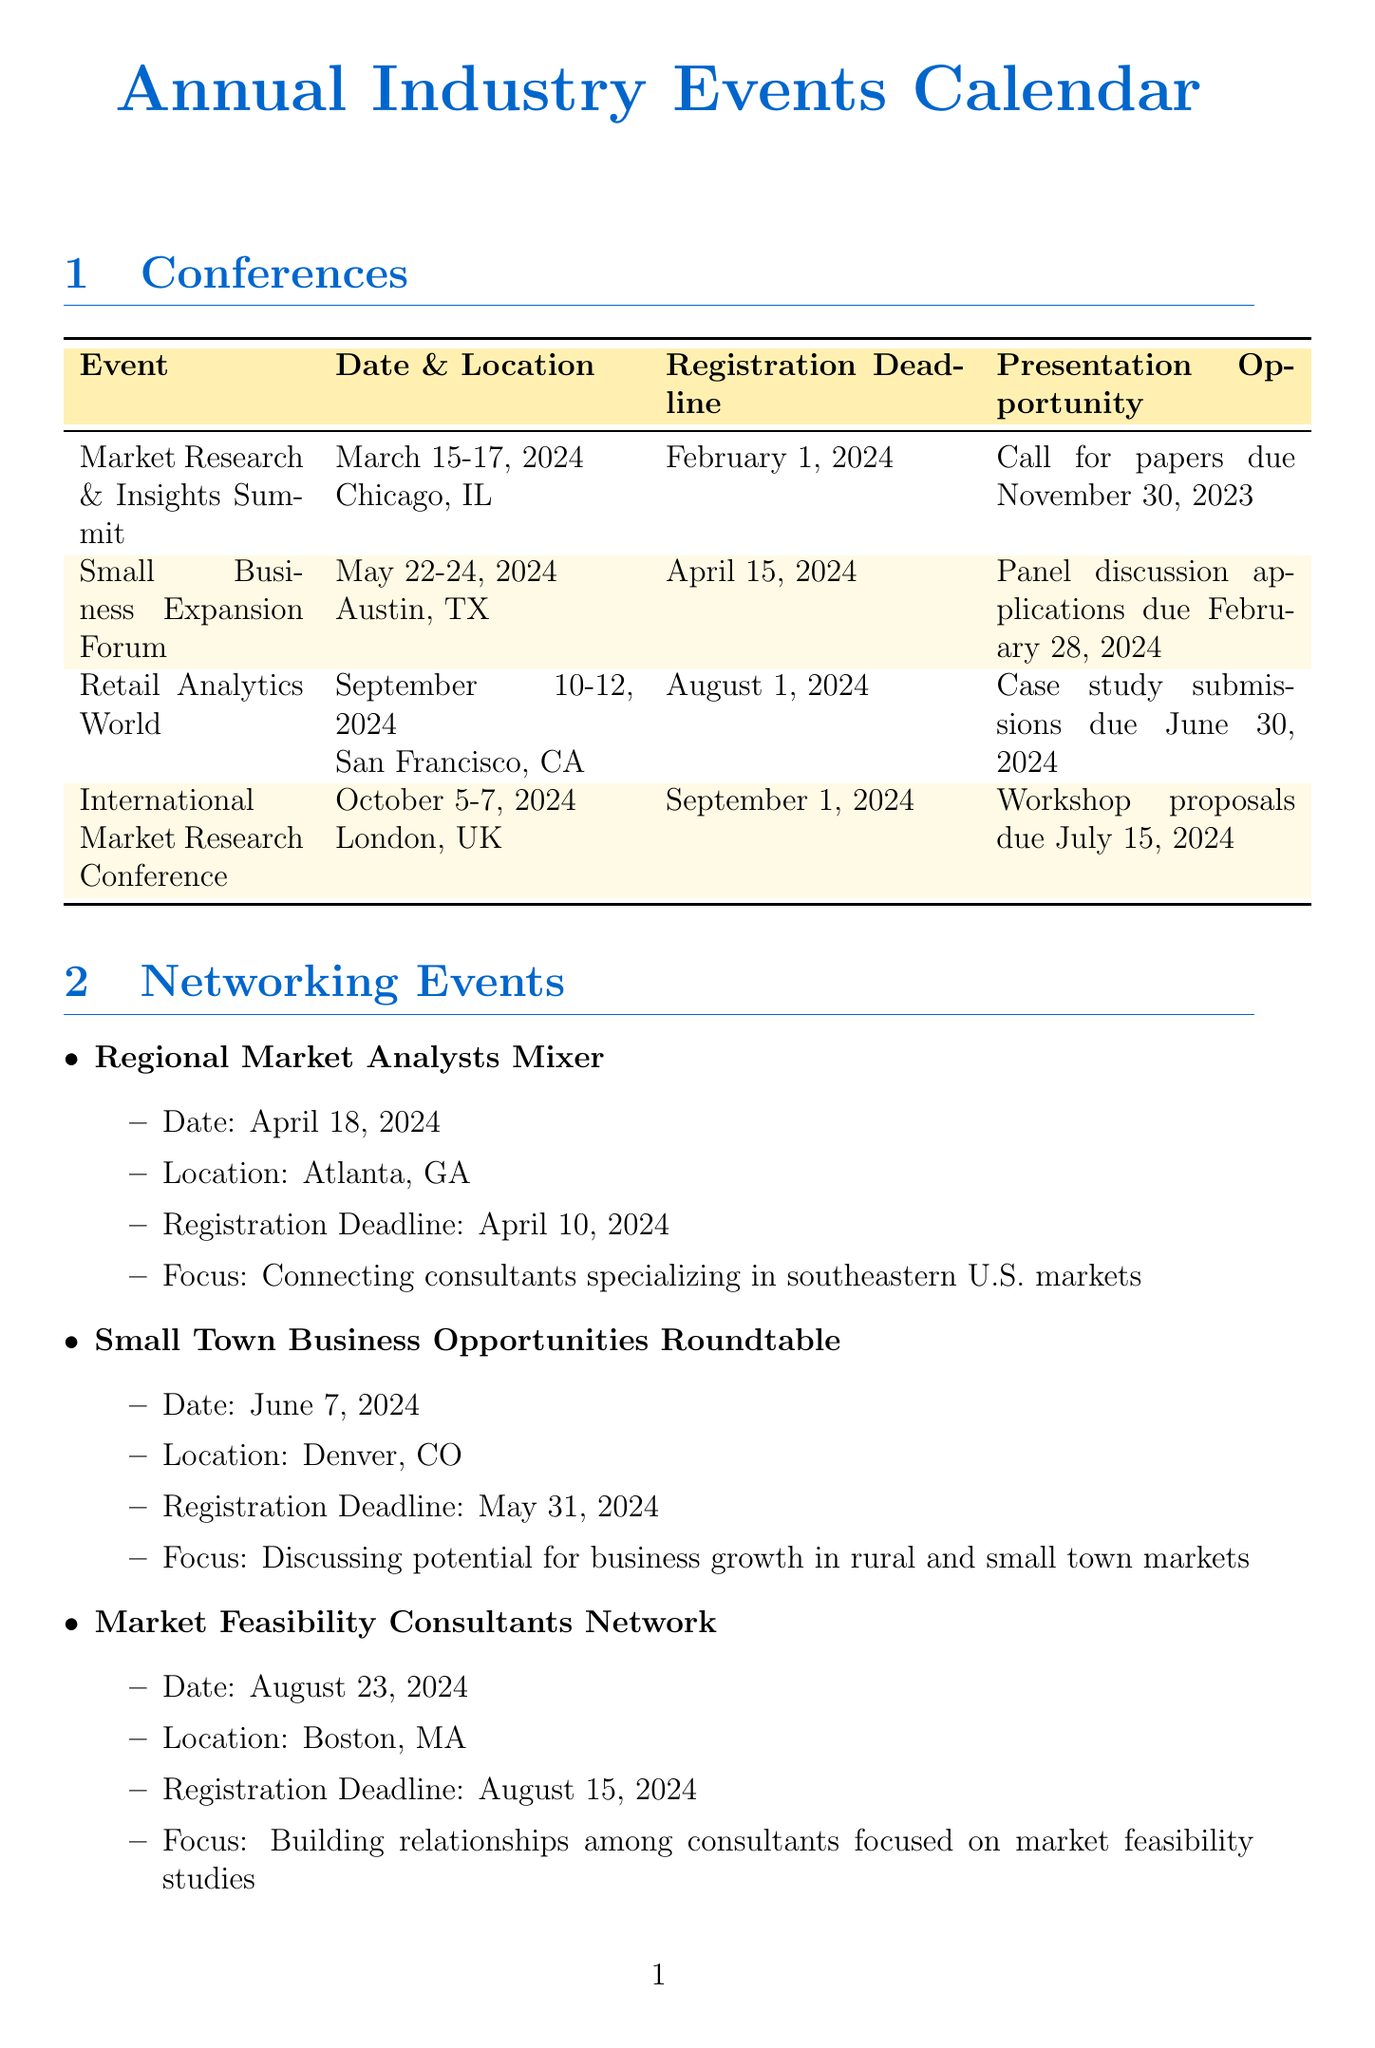what is the location of the Market Research & Insights Summit? The document provides the location for this conference, which is Chicago, IL.
Answer: Chicago, IL when is the registration deadline for the Small Business Expansion Forum? The document specifies that the registration deadline is April 15, 2024.
Answer: April 15, 2024 what is the focus of the International Market Research Conference? The document lists the focus of this conference, which is global perspectives on market analysis and expansion strategies.
Answer: Global perspectives on market analysis and expansion strategies when is the next networking event after the Regional Market Analysts Mixer? The document schedules the Small Town Business Opportunities Roundtable on June 7, 2024, following the Regional Market Analysts Mixer on April 18, 2024.
Answer: June 7, 2024 what is the article submission deadline for the Small Market Business Review? The document states that the submission deadline is the 1st of each month for this publication.
Answer: 1st of each month how many weeks are left to apply for a guest speaker opportunity in the webinar on Leveraging Data for Small Market Expansion? The document indicates the proposal deadline is December 15, 2023, and today is October 23, 2023, meaning there are approximately 7 weeks left.
Answer: 7 weeks which city will host the Retail Analytics World conference? According to the document, the Retail Analytics World conference will be hosted in San Francisco, CA.
Answer: San Francisco, CA what is the focus of the Market Feasibility Consultants Network event? The focus provided in the document is on building relationships among consultants focused on market feasibility studies.
Answer: Building relationships among consultants focused on market feasibility studies 